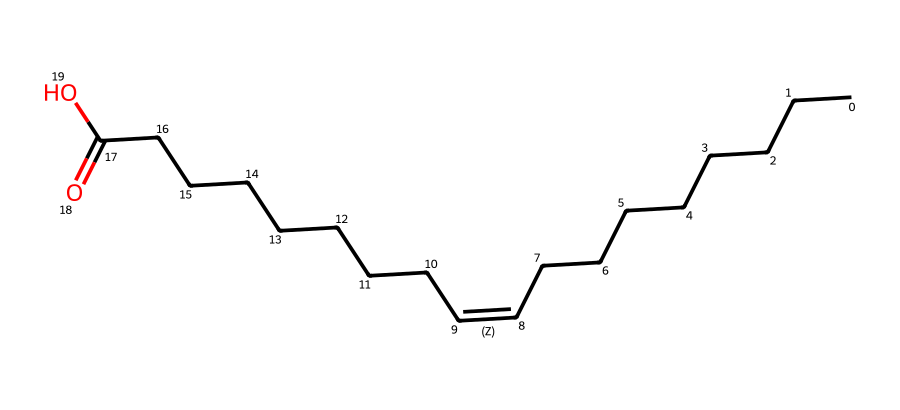What is the name of this chemical? The SMILES representation shows a long carbon chain with a carboxylic acid functional group. This matches the structure of oleic acid, a common fatty acid.
Answer: oleic acid How many carbon atoms are in oleic acid? By analyzing the SMILES, we see there are a total of 18 carbon atoms (CCCCCCCC - 8 on one side of the double bond, C=C - 2 for the double bond itself, and CCCCCCC - 8 on the other side, totaling 18).
Answer: 18 What is the significance of the cis/trans configuration? The presence of a double bond and different arrangements (cis or trans) around the bond affects the physical properties of the compound, including its melting point and saturation.
Answer: physical properties How many hydrogen atoms are attached to oleic acid? For a saturated acyclic hydrocarbon with 18 carbon atoms, the formula would predict 36 hydrogen atoms (C_nH_(2n+2)). However, due to the double bond and carboxylic acid, the total is actually 34 hydrogen atoms (accounting for the hydrogen lost in forming the double bond and the acidic group).
Answer: 34 Which isomer type does oleic acid represent? The presence of a double bond in the structure indicates that oleic acid has geometric isomerism due to the possibility of cis and trans configurations.
Answer: geometric isomerism What type of bonds are present between carbons in oleic acid? The structure contains both single bonds (between the carbons in the chain) and a double bond (indicated by the "C=C").
Answer: single and double bonds 